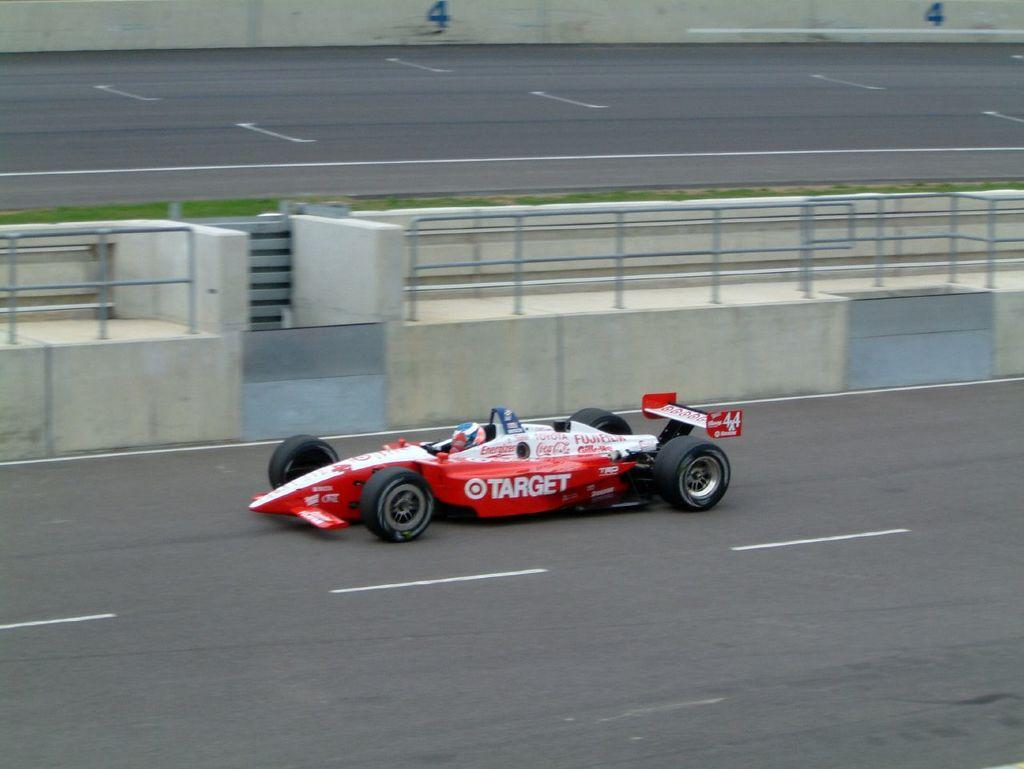What is the person in the image doing? The person is riding a formula one car in the image. Where is the car located? The car is on the road. What type of fencing can be seen in the image? There is stainless steel fencing visible in the image. What type of vegetation is present on the side of the road? There is green grass on the side of the road. What nation is the person supporting while riding the formula one car in the image? There is no indication in the image of which nation the person might be supporting. 